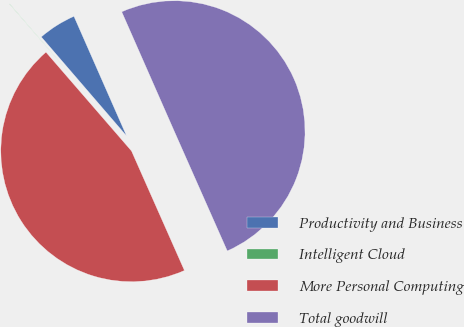Convert chart to OTSL. <chart><loc_0><loc_0><loc_500><loc_500><pie_chart><fcel>Productivity and Business<fcel>Intelligent Cloud<fcel>More Personal Computing<fcel>Total goodwill<nl><fcel>4.72%<fcel>0.04%<fcel>45.28%<fcel>49.96%<nl></chart> 